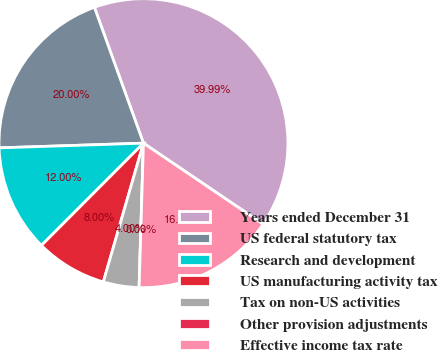<chart> <loc_0><loc_0><loc_500><loc_500><pie_chart><fcel>Years ended December 31<fcel>US federal statutory tax<fcel>Research and development<fcel>US manufacturing activity tax<fcel>Tax on non-US activities<fcel>Other provision adjustments<fcel>Effective income tax rate<nl><fcel>39.99%<fcel>20.0%<fcel>12.0%<fcel>8.0%<fcel>4.0%<fcel>0.0%<fcel>16.0%<nl></chart> 